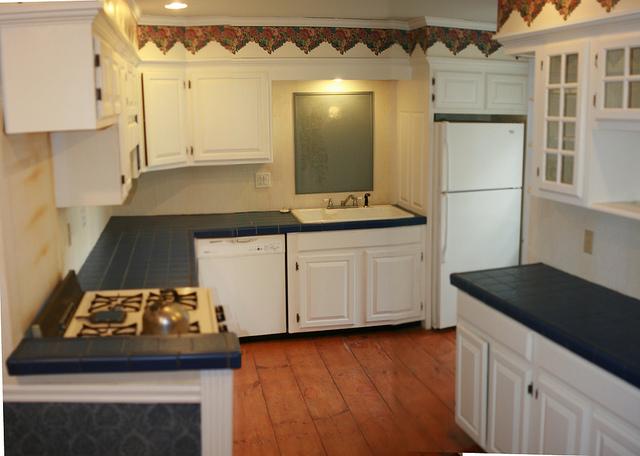What room is this?
Keep it brief. Kitchen. Is this house occupied?
Keep it brief. No. Is there a ladder in the picture?
Answer briefly. No. How many sinks are there?
Answer briefly. 1. 